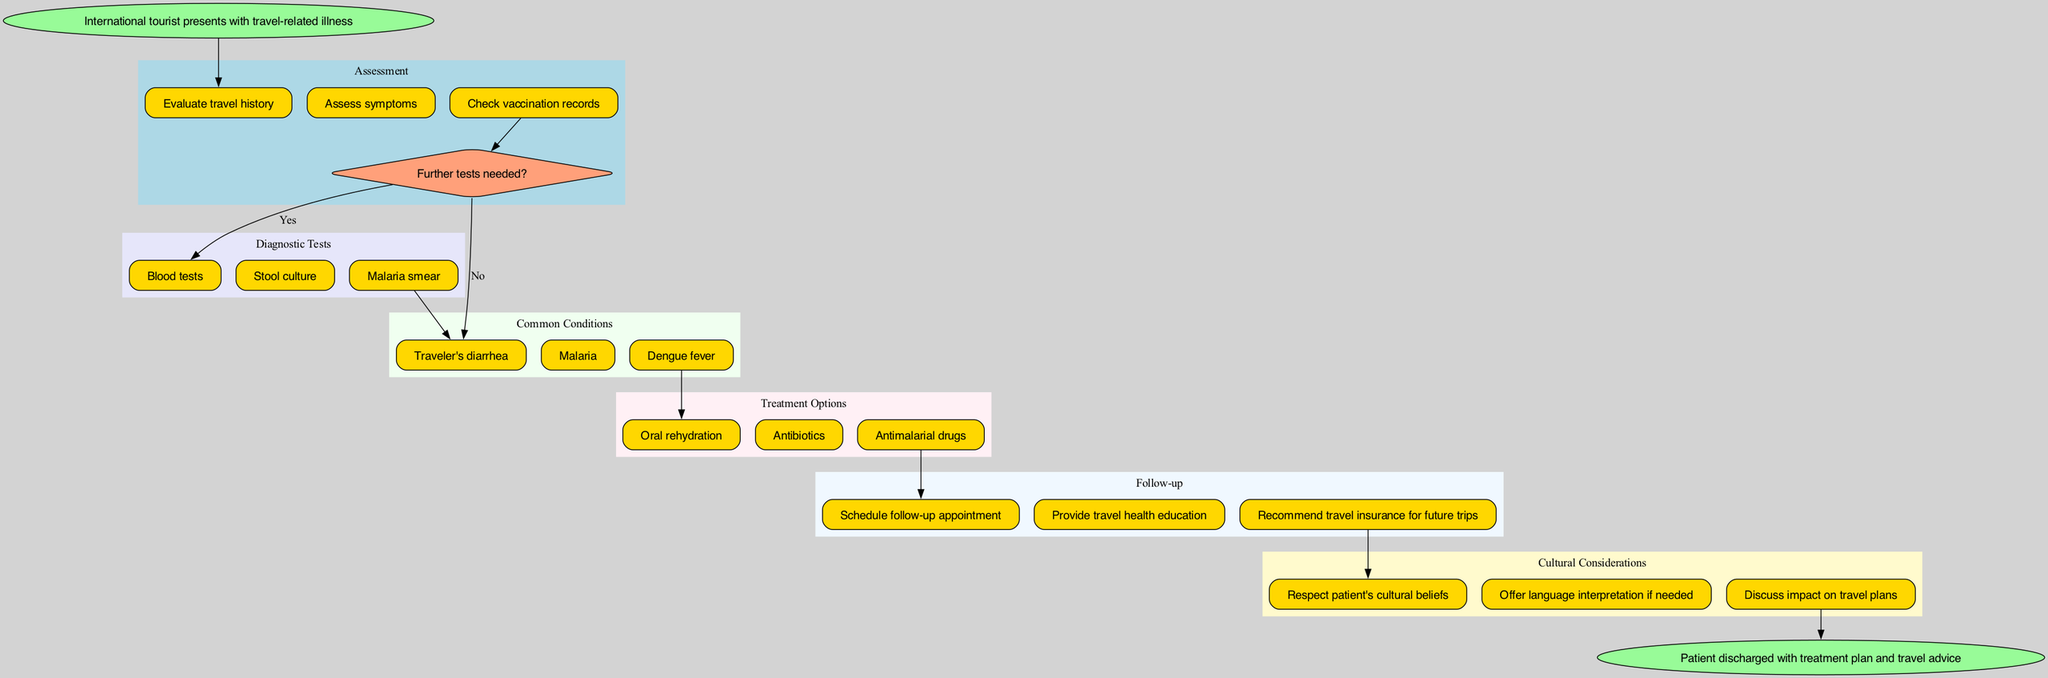What is the starting point of the clinical pathway? The starting point is indicated by the 'start' node in the diagram, which states 'International tourist presents with travel-related illness.'
Answer: International tourist presents with travel-related illness How many assessment steps are there? By counting the nodes in the 'Assessment' section of the diagram, we can determine that there are three assessment steps.
Answer: 3 What type of tests are conducted during the clinical pathway? The 'Diagnostic Tests' section specifies the tests conducted, which include 'Blood tests,' 'Stool culture,' and 'Malaria smear.'
Answer: Blood tests, Stool culture, Malaria smear If further tests are needed, which condition might be assessed next? According to the flow of the diagram, if further tests are needed, the next possible condition assessed could be 'Traveler's diarrhea,' as it flows from the assessment decision to the condition nodes.
Answer: Traveler's diarrhea What treatment is recommended after identifying Dengue fever? The diagram shows that if Dengue fever is identified, the treatment option prescribed is 'Antimalarial drugs.'
Answer: Antimalarial drugs What follows the treatment options in the clinical pathway? After the 'Treatment Options' section, the next component in the pathway is 'Follow-up,' where follow-up actions are outlined for the patient.
Answer: Follow-up How does the pathway accommodate cultural considerations? The 'Cultural Considerations' section of the diagram notes three specific actions to respect the patient's cultural background, leading to better health outcomes during treatment.
Answer: Respect patient's cultural beliefs Which node follows the cultural considerations section? The end of the pathway is indicated by the 'End' node, which states the conclusion of the clinical pathway: 'Patient discharged with treatment plan and travel advice.'
Answer: Patient discharged with treatment plan and travel advice What is one common condition identified in international tourists? The diagram lists three common conditions, and one of them is 'Malaria,' which is found in the 'Common Conditions' section.
Answer: Malaria 